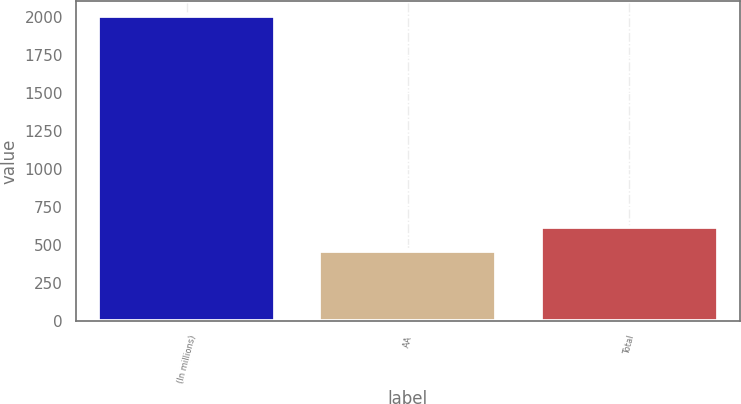<chart> <loc_0><loc_0><loc_500><loc_500><bar_chart><fcel>(In millions)<fcel>AA<fcel>Total<nl><fcel>2006<fcel>459<fcel>618<nl></chart> 